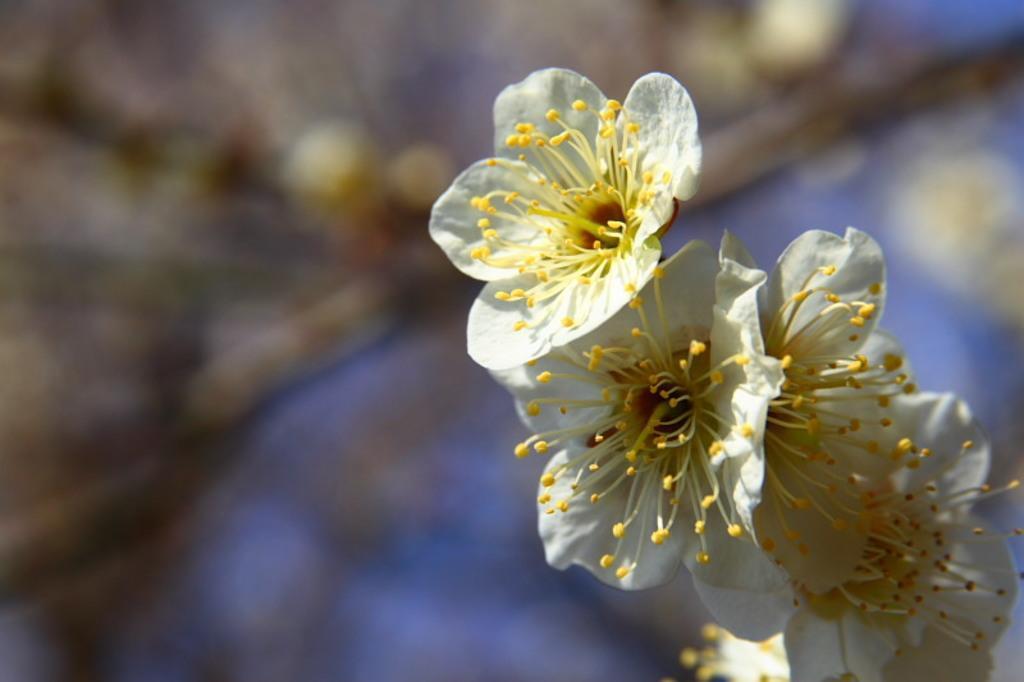Can you describe this image briefly? On the right side, there are white color flowers of a tree. And the background is blurred. 